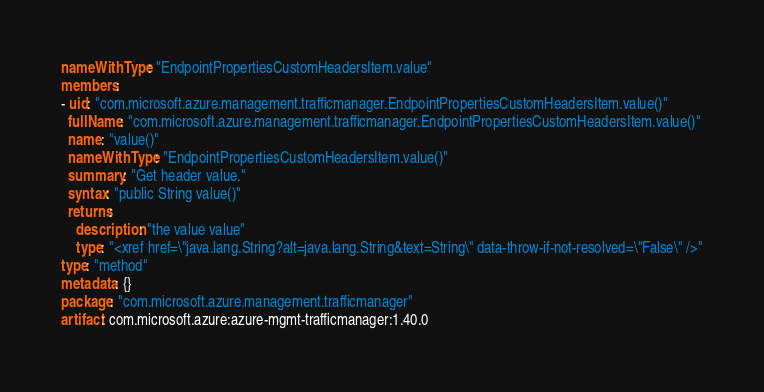<code> <loc_0><loc_0><loc_500><loc_500><_YAML_>nameWithType: "EndpointPropertiesCustomHeadersItem.value"
members:
- uid: "com.microsoft.azure.management.trafficmanager.EndpointPropertiesCustomHeadersItem.value()"
  fullName: "com.microsoft.azure.management.trafficmanager.EndpointPropertiesCustomHeadersItem.value()"
  name: "value()"
  nameWithType: "EndpointPropertiesCustomHeadersItem.value()"
  summary: "Get header value."
  syntax: "public String value()"
  returns:
    description: "the value value"
    type: "<xref href=\"java.lang.String?alt=java.lang.String&text=String\" data-throw-if-not-resolved=\"False\" />"
type: "method"
metadata: {}
package: "com.microsoft.azure.management.trafficmanager"
artifact: com.microsoft.azure:azure-mgmt-trafficmanager:1.40.0
</code> 